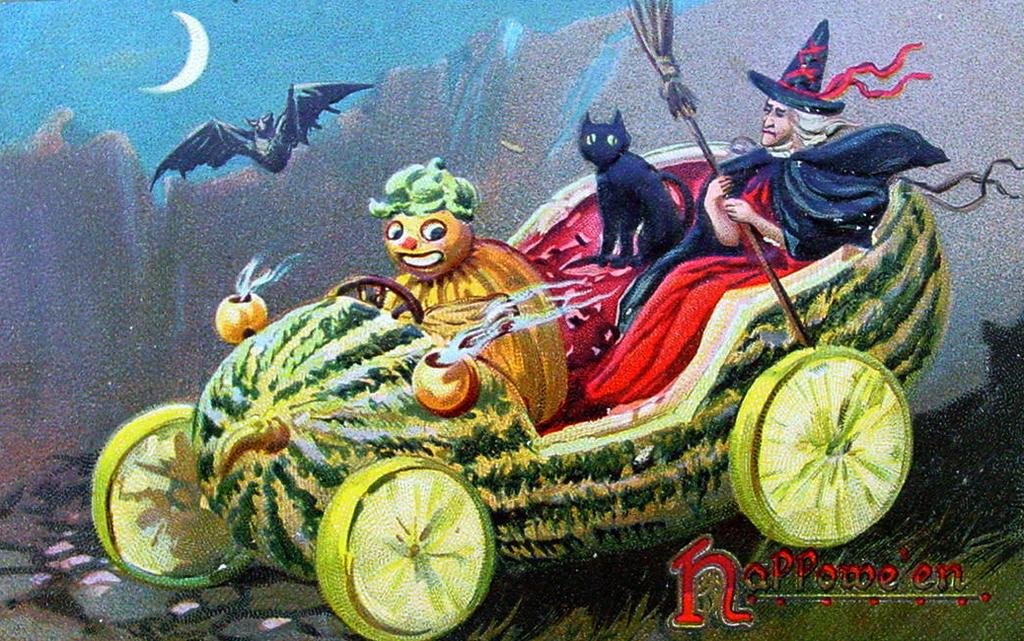What type of artwork is depicted in the image? The image is a painting of a cartoon. What can be seen in the background of the painting? There is a bat, a moon, and a sky in the background of the image. What type of zephyr is blowing through the leaves in the image? There is no zephyr or leaves present in the image; it is a painting of a cartoon with a bat, a moon, and a sky in the background. 